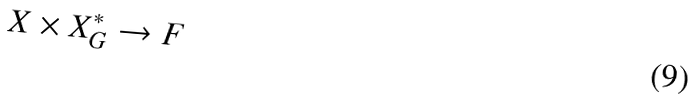<formula> <loc_0><loc_0><loc_500><loc_500>X \times X _ { G } ^ { * } \rightarrow F</formula> 